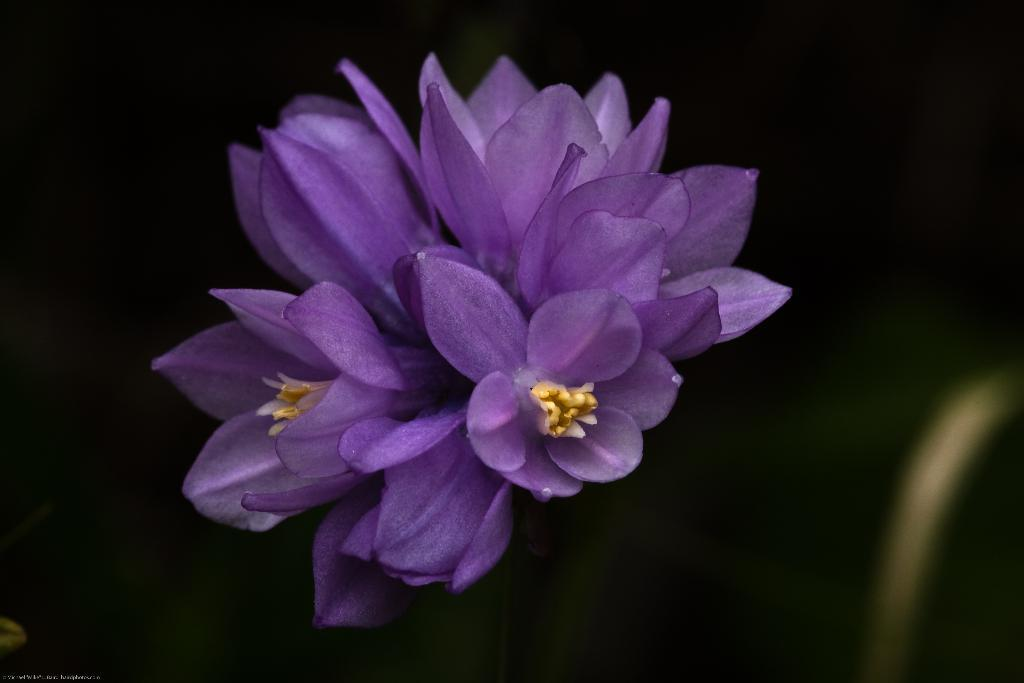What type of living organisms can be seen in the image? There are flowers in the image. What colors are the flowers? The flowers are violet, yellow, and white in color. What can be observed about the background of the image? The background of the image is dark. How many trees can be seen in the image? There are no trees visible in the image; it features flowers. What type of pancake is being used to hold the flowers in the image? There is no pancake present in the image; it features flowers without any additional objects or supports. 